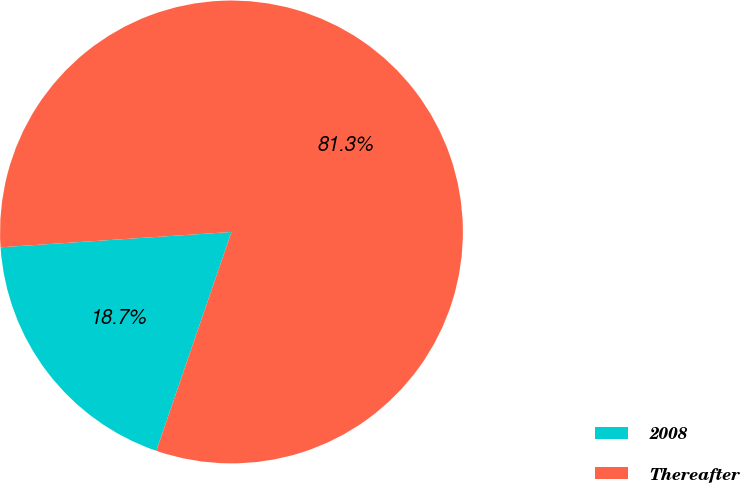Convert chart. <chart><loc_0><loc_0><loc_500><loc_500><pie_chart><fcel>2008<fcel>Thereafter<nl><fcel>18.68%<fcel>81.32%<nl></chart> 